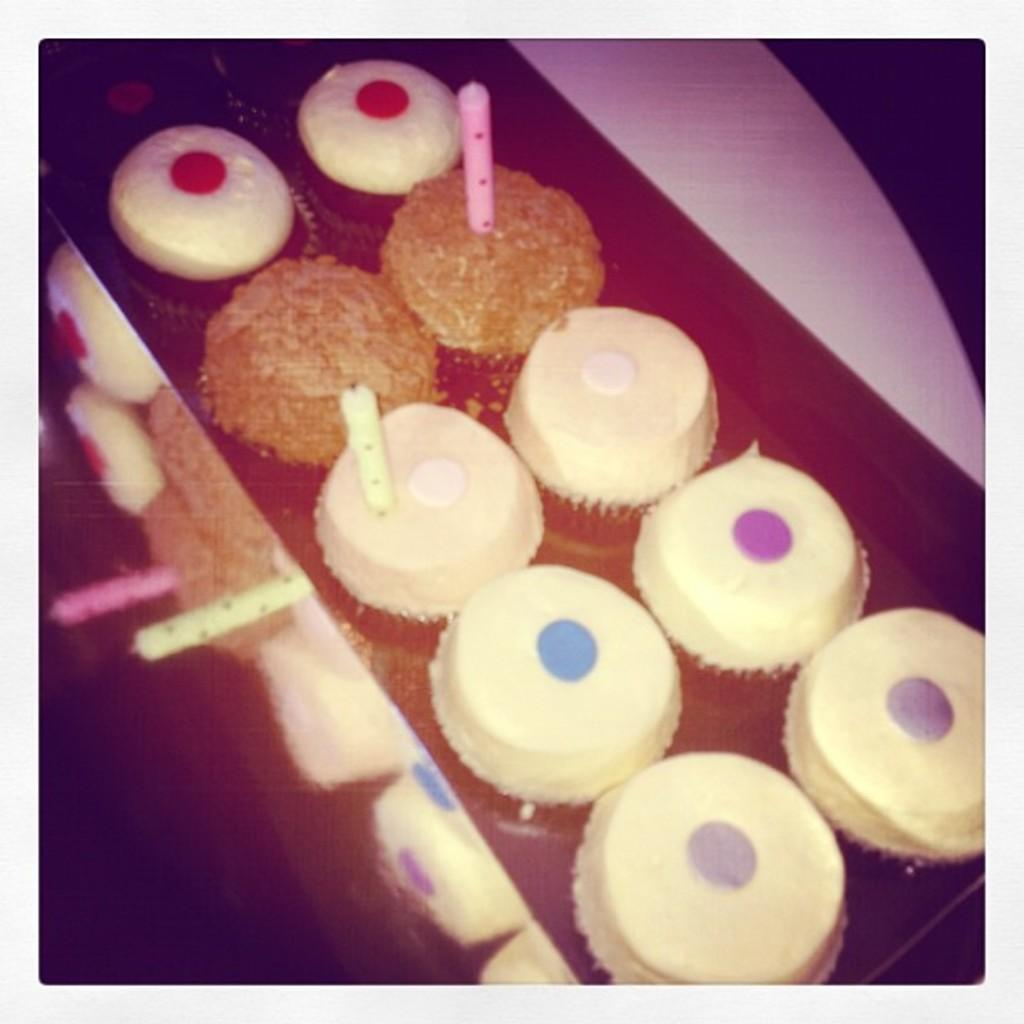What type of furniture is present in the image? There is a table in the image. What can be seen on or around the table? There are colorful food items visible in the image. How many girls are sitting at the table in the image? There is no girl present in the image; it only features a table and colorful food items. 